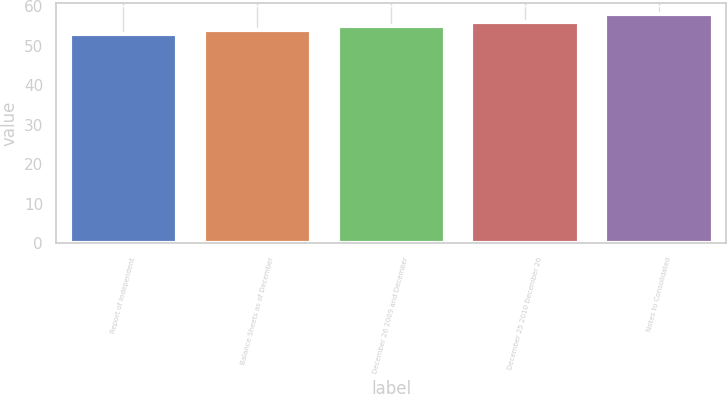Convert chart. <chart><loc_0><loc_0><loc_500><loc_500><bar_chart><fcel>Report of Independent<fcel>Balance Sheets as of December<fcel>December 26 2009 and December<fcel>December 25 2010 December 26<fcel>Notes to Consolidated<nl><fcel>53<fcel>54<fcel>55<fcel>56<fcel>58<nl></chart> 